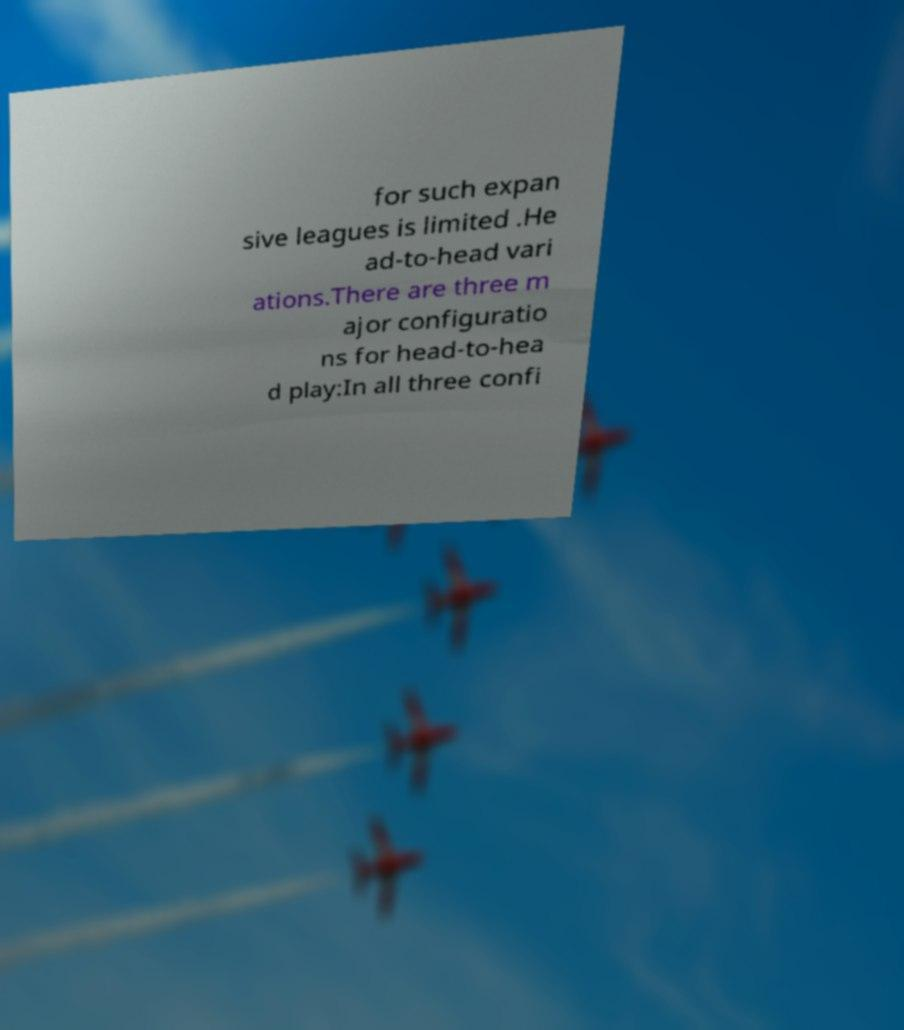Please identify and transcribe the text found in this image. for such expan sive leagues is limited .He ad-to-head vari ations.There are three m ajor configuratio ns for head-to-hea d play:In all three confi 